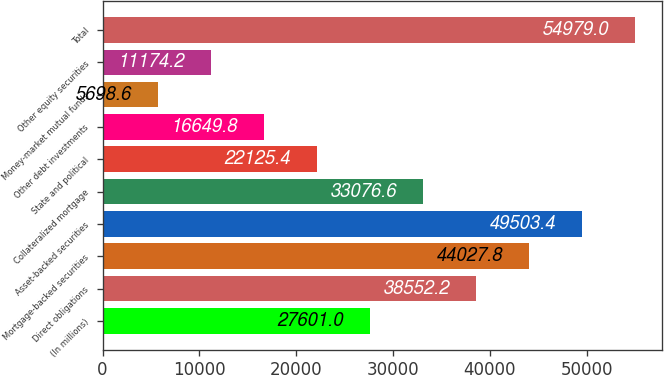<chart> <loc_0><loc_0><loc_500><loc_500><bar_chart><fcel>(In millions)<fcel>Direct obligations<fcel>Mortgage-backed securities<fcel>Asset-backed securities<fcel>Collateralized mortgage<fcel>State and political<fcel>Other debt investments<fcel>Money-market mutual funds<fcel>Other equity securities<fcel>Total<nl><fcel>27601<fcel>38552.2<fcel>44027.8<fcel>49503.4<fcel>33076.6<fcel>22125.4<fcel>16649.8<fcel>5698.6<fcel>11174.2<fcel>54979<nl></chart> 